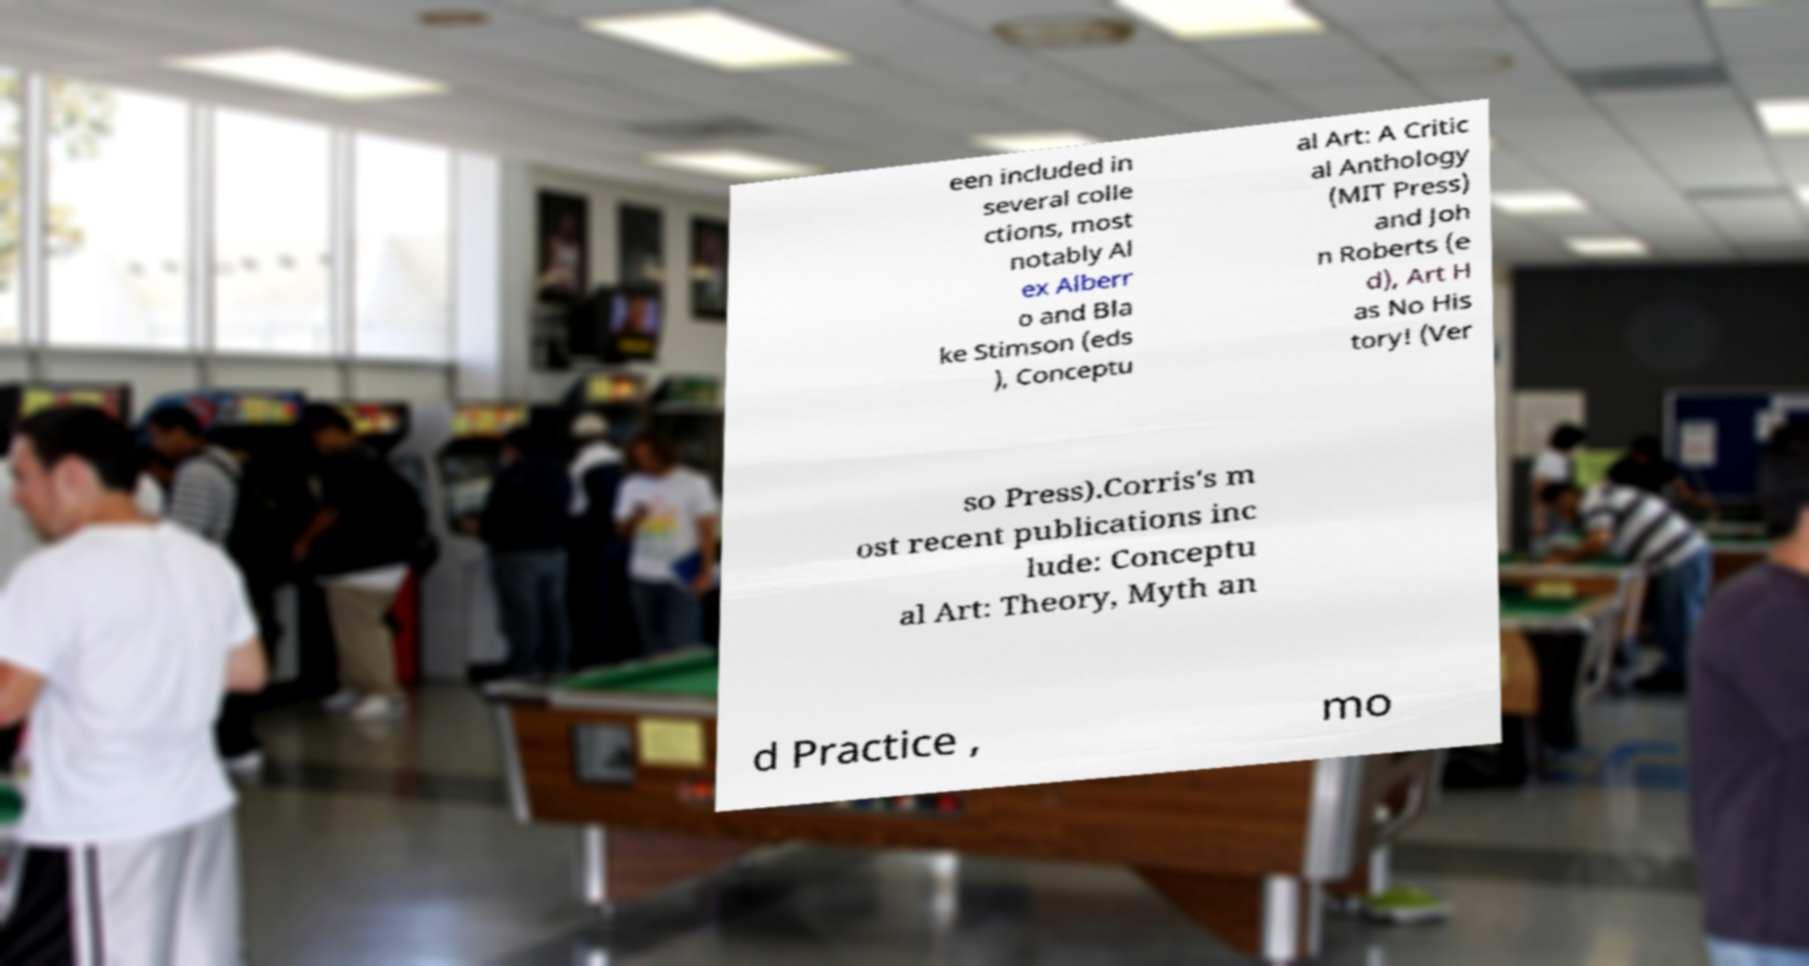Can you accurately transcribe the text from the provided image for me? een included in several colle ctions, most notably Al ex Alberr o and Bla ke Stimson (eds ), Conceptu al Art: A Critic al Anthology (MIT Press) and Joh n Roberts (e d), Art H as No His tory! (Ver so Press).Corris's m ost recent publications inc lude: Conceptu al Art: Theory, Myth an d Practice , mo 